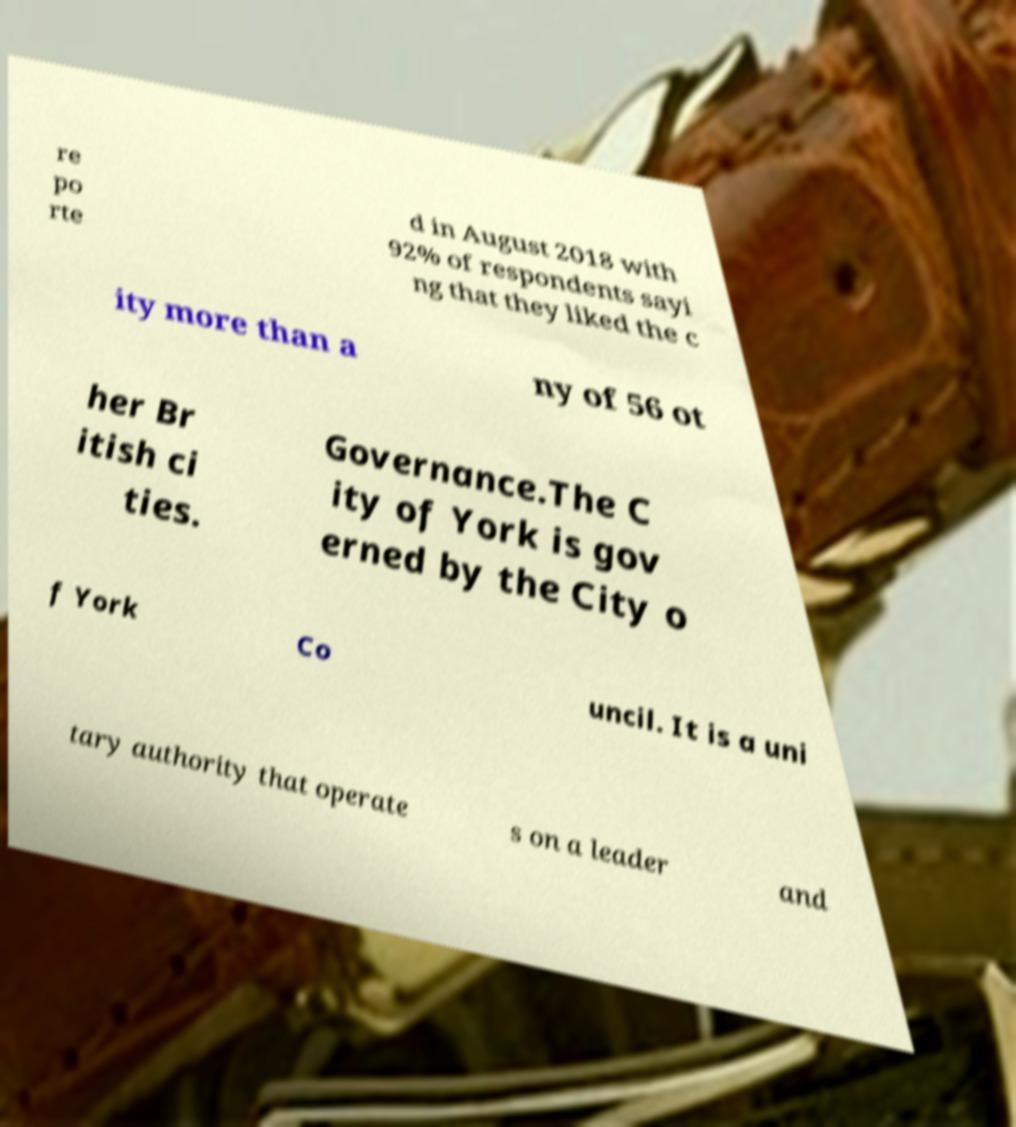Can you accurately transcribe the text from the provided image for me? re po rte d in August 2018 with 92% of respondents sayi ng that they liked the c ity more than a ny of 56 ot her Br itish ci ties. Governance.The C ity of York is gov erned by the City o f York Co uncil. It is a uni tary authority that operate s on a leader and 